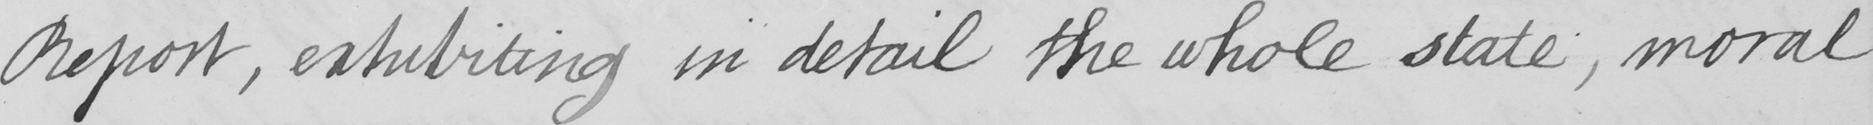Can you read and transcribe this handwriting? Report , exhibiting in detail the whole state , moral 